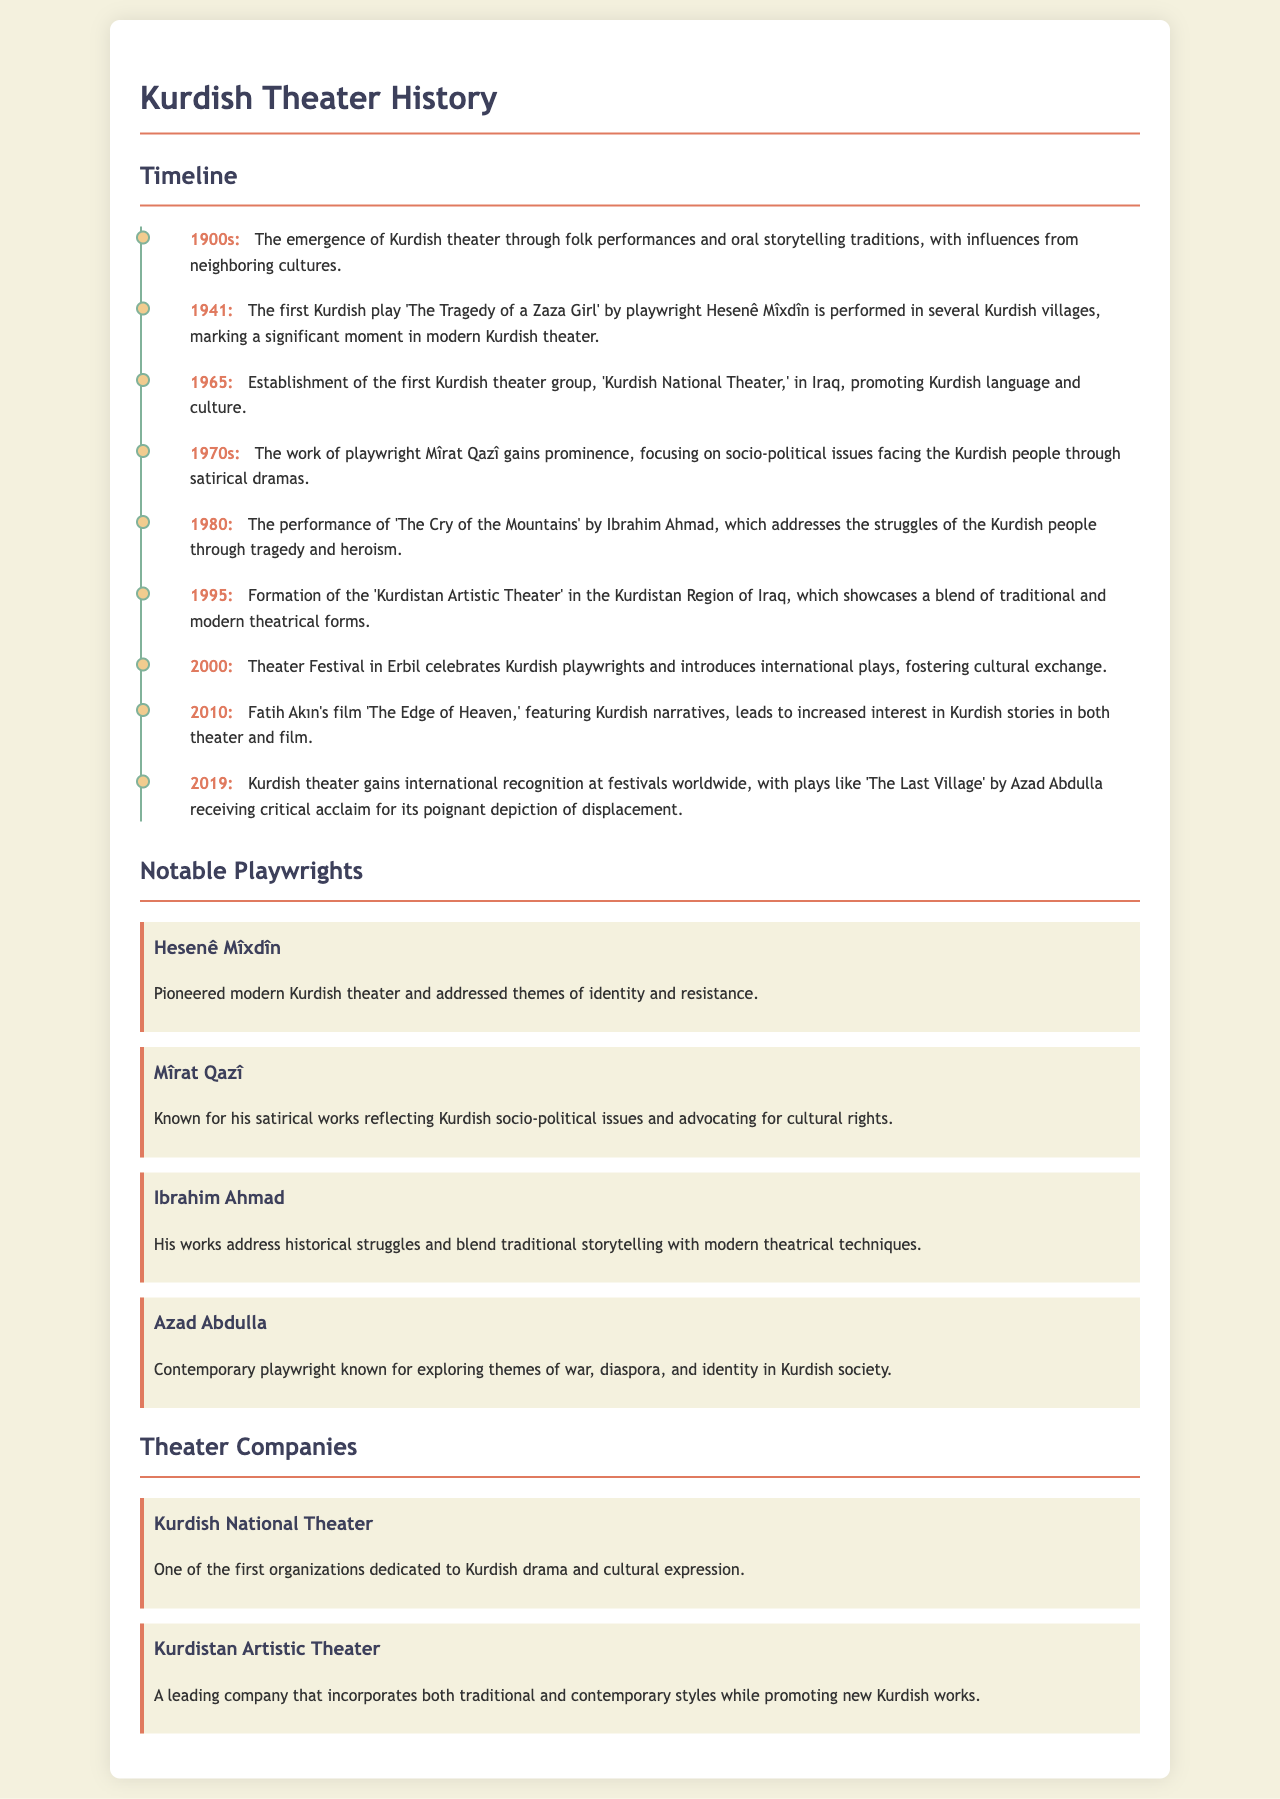What year was the first Kurdish play performed? The document states that the first Kurdish play 'The Tragedy of a Zaza Girl' was performed in 1941.
Answer: 1941 Who is known for exploring themes of war and identity? Azad Abdulla is a contemporary playwright known for exploring these themes in Kurdish society.
Answer: Azad Abdulla What significant event took place in 2000? The document mentions a theater festival in Erbil that celebrated Kurdish playwrights and introduced international plays.
Answer: Theater Festival in Erbil Which playwright's work gained prominence in the 1970s? The document indicates that Mîrat Qazî's work gained prominence during the 1970s, focusing on socio-political issues.
Answer: Mîrat Qazî What is one of the first organizations dedicated to Kurdish theater? The document references the Kurdish National Theater as one of the first dedicated organizations for Kurdish drama.
Answer: Kurdish National Theater In what decade did the Kurdish theater start emerging? The timeline mentions that the emergence of Kurdish theater began in the 1900s through folk performances and oral storytelling traditions.
Answer: 1900s What type of issues did Ibrahim Ahmad address in his play? His play 'The Cry of the Mountains' addresses the struggles of the Kurdish people through tragedy and heroism.
Answer: Struggles of the Kurdish people What notable play received critical acclaim in 2019? The document states that 'The Last Village' by Azad Abdulla received critical acclaim in 2019.
Answer: The Last Village 